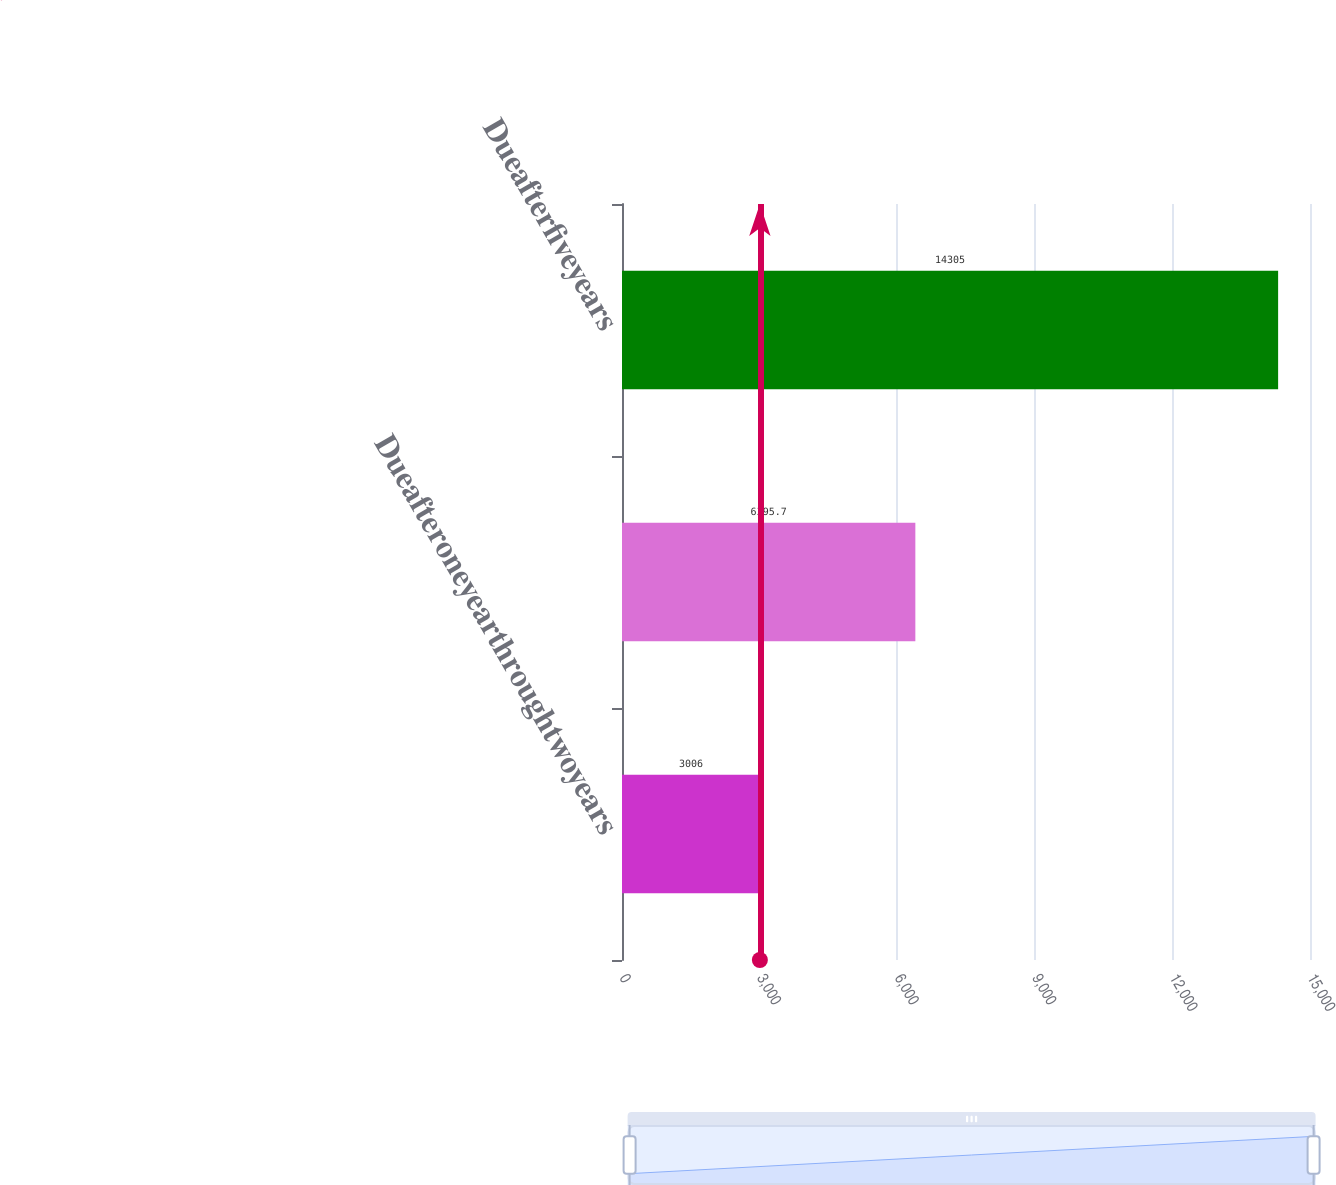<chart> <loc_0><loc_0><loc_500><loc_500><bar_chart><fcel>Dueafteroneyearthroughtwoyears<fcel>Unnamed: 1<fcel>Dueafterfiveyears<nl><fcel>3006<fcel>6395.7<fcel>14305<nl></chart> 